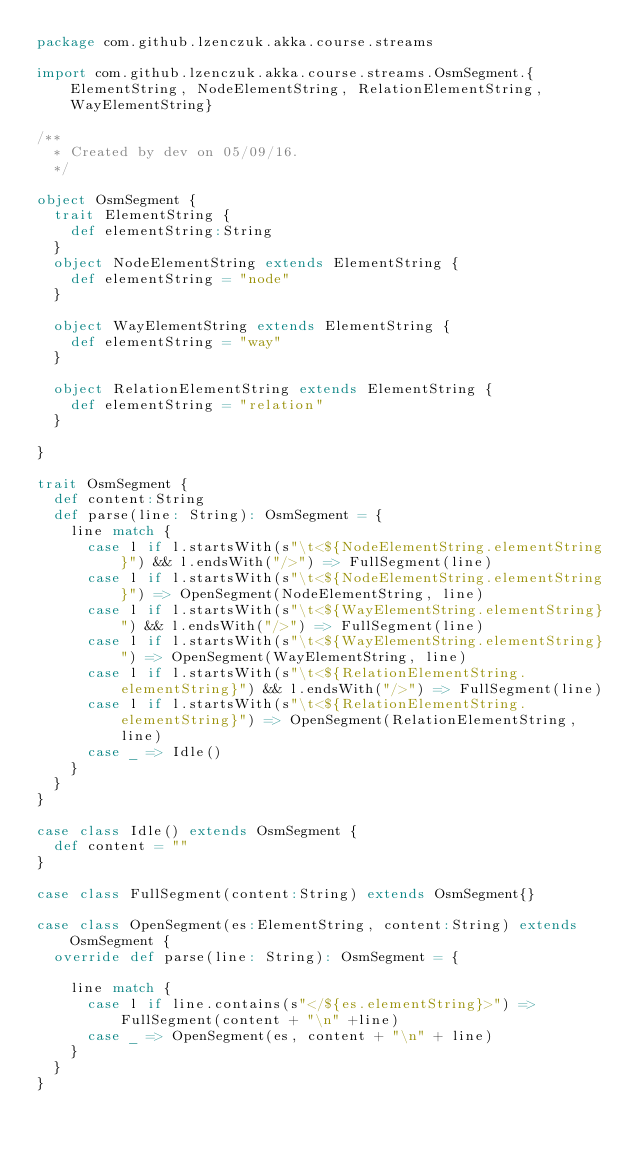Convert code to text. <code><loc_0><loc_0><loc_500><loc_500><_Scala_>package com.github.lzenczuk.akka.course.streams

import com.github.lzenczuk.akka.course.streams.OsmSegment.{ElementString, NodeElementString, RelationElementString, WayElementString}

/**
  * Created by dev on 05/09/16.
  */

object OsmSegment {
  trait ElementString {
    def elementString:String
  }
  object NodeElementString extends ElementString {
    def elementString = "node"
  }

  object WayElementString extends ElementString {
    def elementString = "way"
  }

  object RelationElementString extends ElementString {
    def elementString = "relation"
  }

}

trait OsmSegment {
  def content:String
  def parse(line: String): OsmSegment = {
    line match {
      case l if l.startsWith(s"\t<${NodeElementString.elementString}") && l.endsWith("/>") => FullSegment(line)
      case l if l.startsWith(s"\t<${NodeElementString.elementString}") => OpenSegment(NodeElementString, line)
      case l if l.startsWith(s"\t<${WayElementString.elementString}") && l.endsWith("/>") => FullSegment(line)
      case l if l.startsWith(s"\t<${WayElementString.elementString}") => OpenSegment(WayElementString, line)
      case l if l.startsWith(s"\t<${RelationElementString.elementString}") && l.endsWith("/>") => FullSegment(line)
      case l if l.startsWith(s"\t<${RelationElementString.elementString}") => OpenSegment(RelationElementString, line)
      case _ => Idle()
    }
  }
}

case class Idle() extends OsmSegment {
  def content = ""
}

case class FullSegment(content:String) extends OsmSegment{}

case class OpenSegment(es:ElementString, content:String) extends OsmSegment {
  override def parse(line: String): OsmSegment = {

    line match {
      case l if line.contains(s"</${es.elementString}>") => FullSegment(content + "\n" +line)
      case _ => OpenSegment(es, content + "\n" + line)
    }
  }
}

</code> 